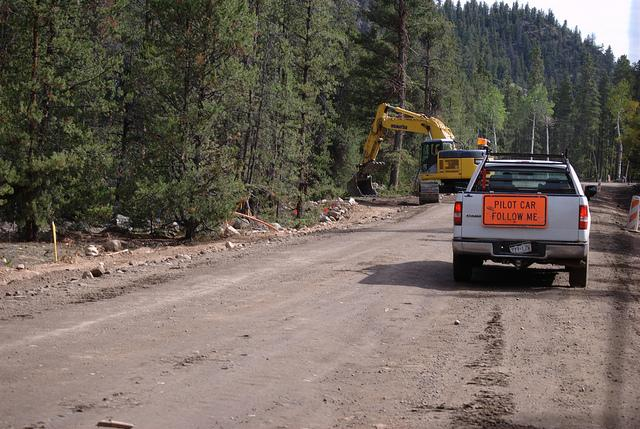What are you instructed to do? Please explain your reasoning. follow car. The pilot car wants the other vehicles to follow him. 